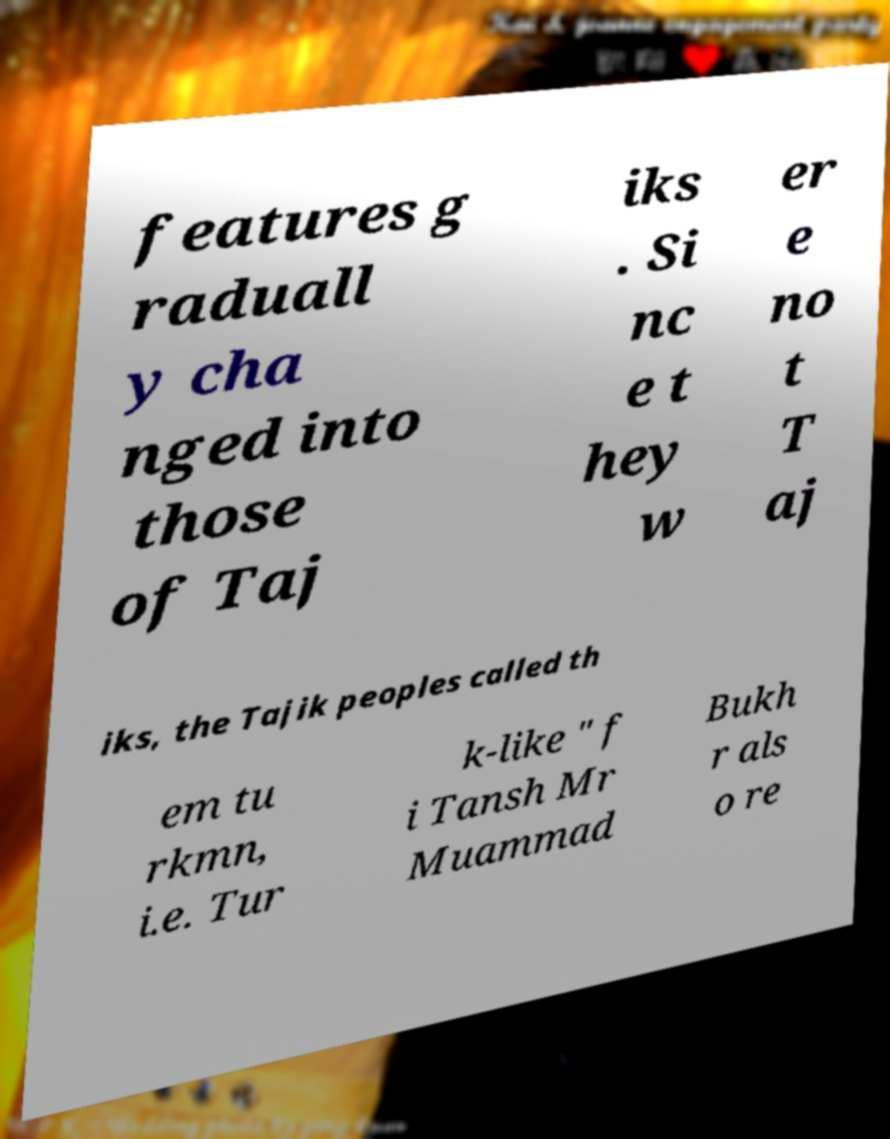There's text embedded in this image that I need extracted. Can you transcribe it verbatim? features g raduall y cha nged into those of Taj iks . Si nc e t hey w er e no t T aj iks, the Tajik peoples called th em tu rkmn, i.e. Tur k-like " f i Tansh Mr Muammad Bukh r als o re 